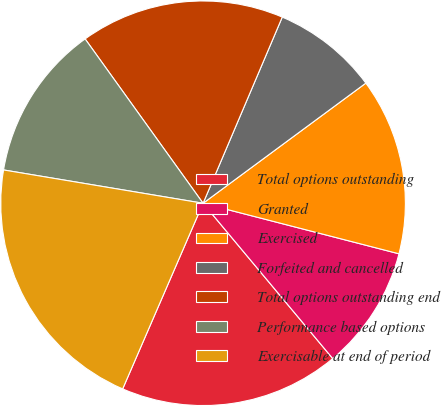<chart> <loc_0><loc_0><loc_500><loc_500><pie_chart><fcel>Total options outstanding<fcel>Granted<fcel>Exercised<fcel>Forfeited and cancelled<fcel>Total options outstanding end<fcel>Performance based options<fcel>Exercisable at end of period<nl><fcel>17.58%<fcel>9.91%<fcel>14.14%<fcel>8.48%<fcel>16.31%<fcel>12.46%<fcel>21.13%<nl></chart> 